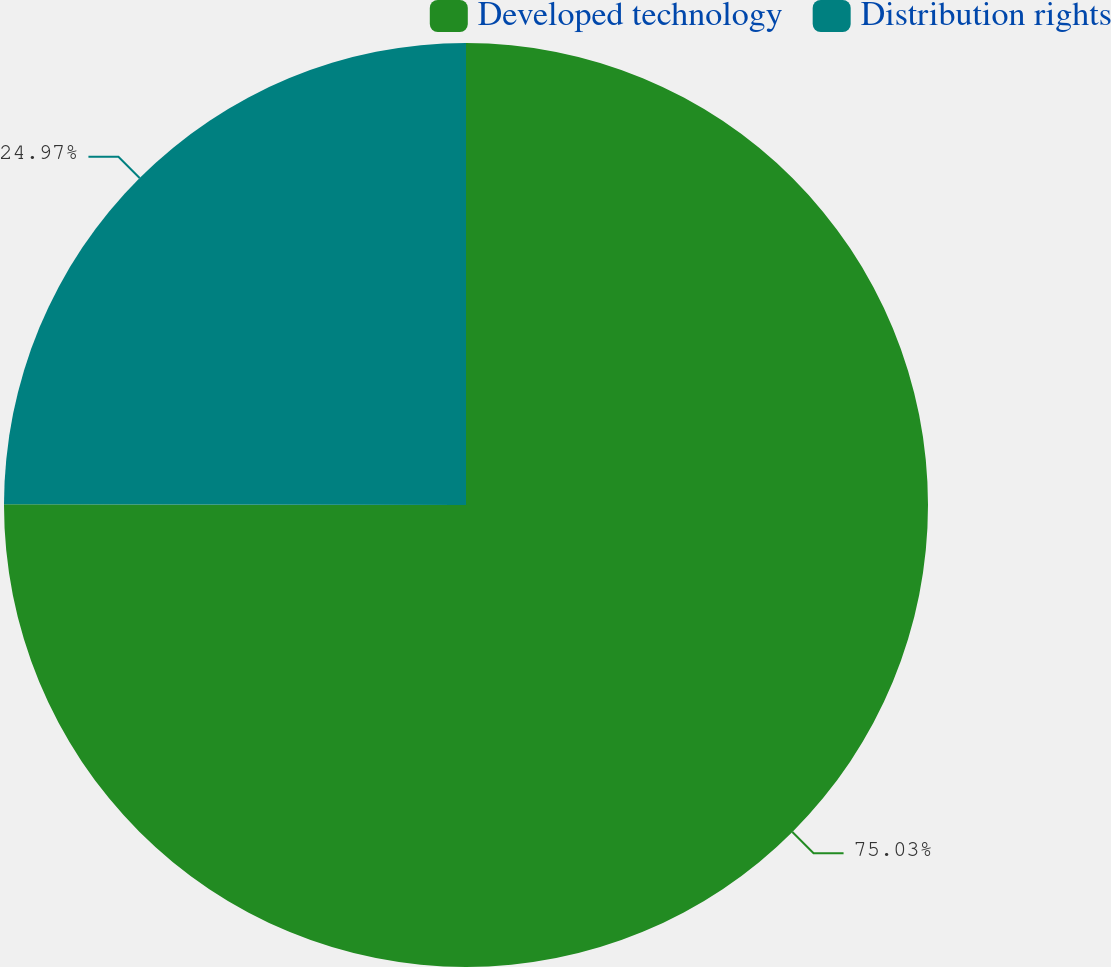Convert chart to OTSL. <chart><loc_0><loc_0><loc_500><loc_500><pie_chart><fcel>Developed technology<fcel>Distribution rights<nl><fcel>75.03%<fcel>24.97%<nl></chart> 